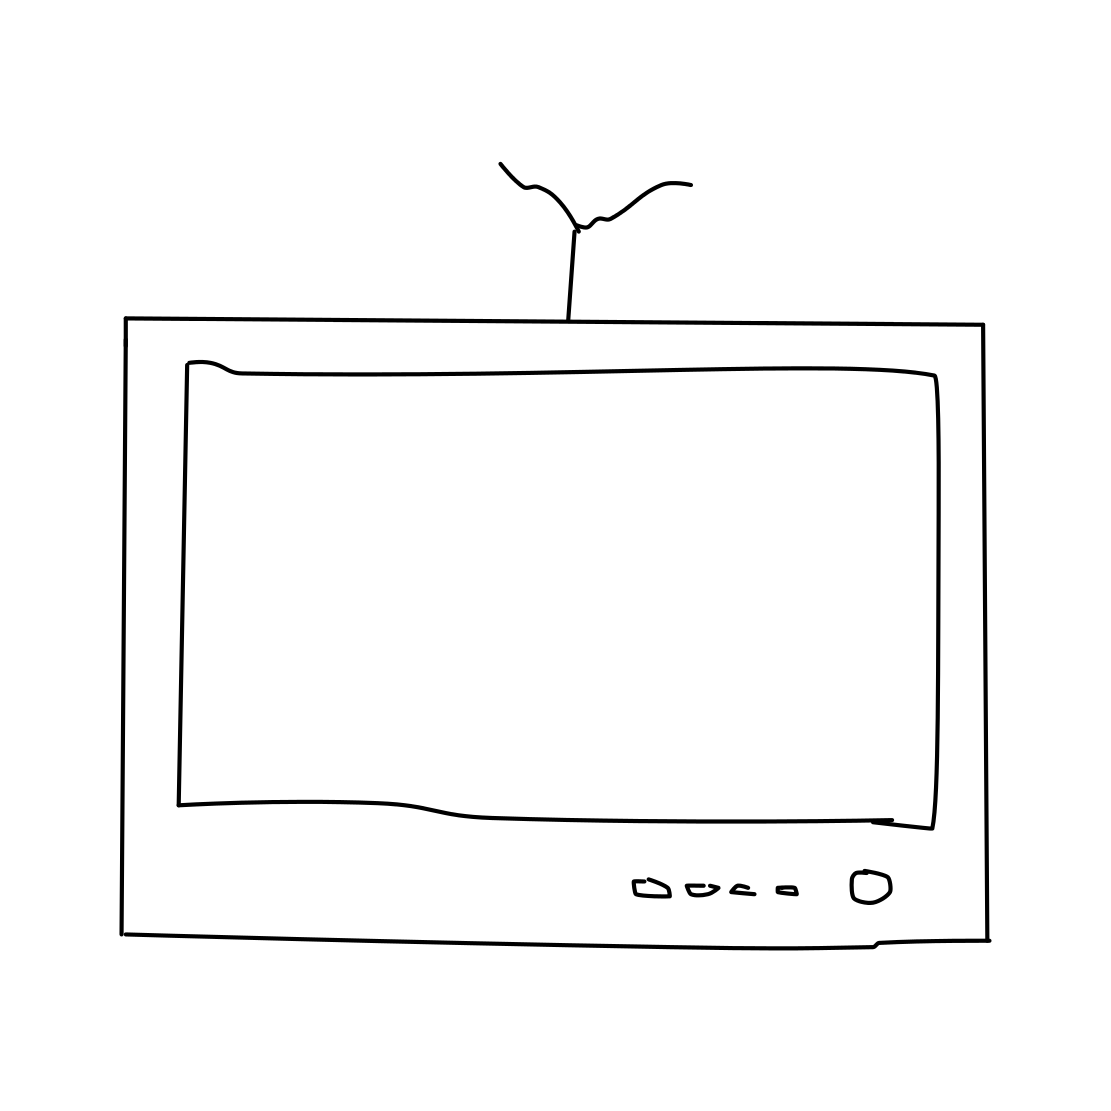Could you tell me more about the style of this drawing? Certainly! The drawing is rendered in a sketchy style, characterized by loose, expressive lines that give a hand-drawn and informal look. This style often conveys a sense of immediacy and personality, indicating it might be part of a conceptual design, a storyboard for an animation, or simply an artistic expression. 